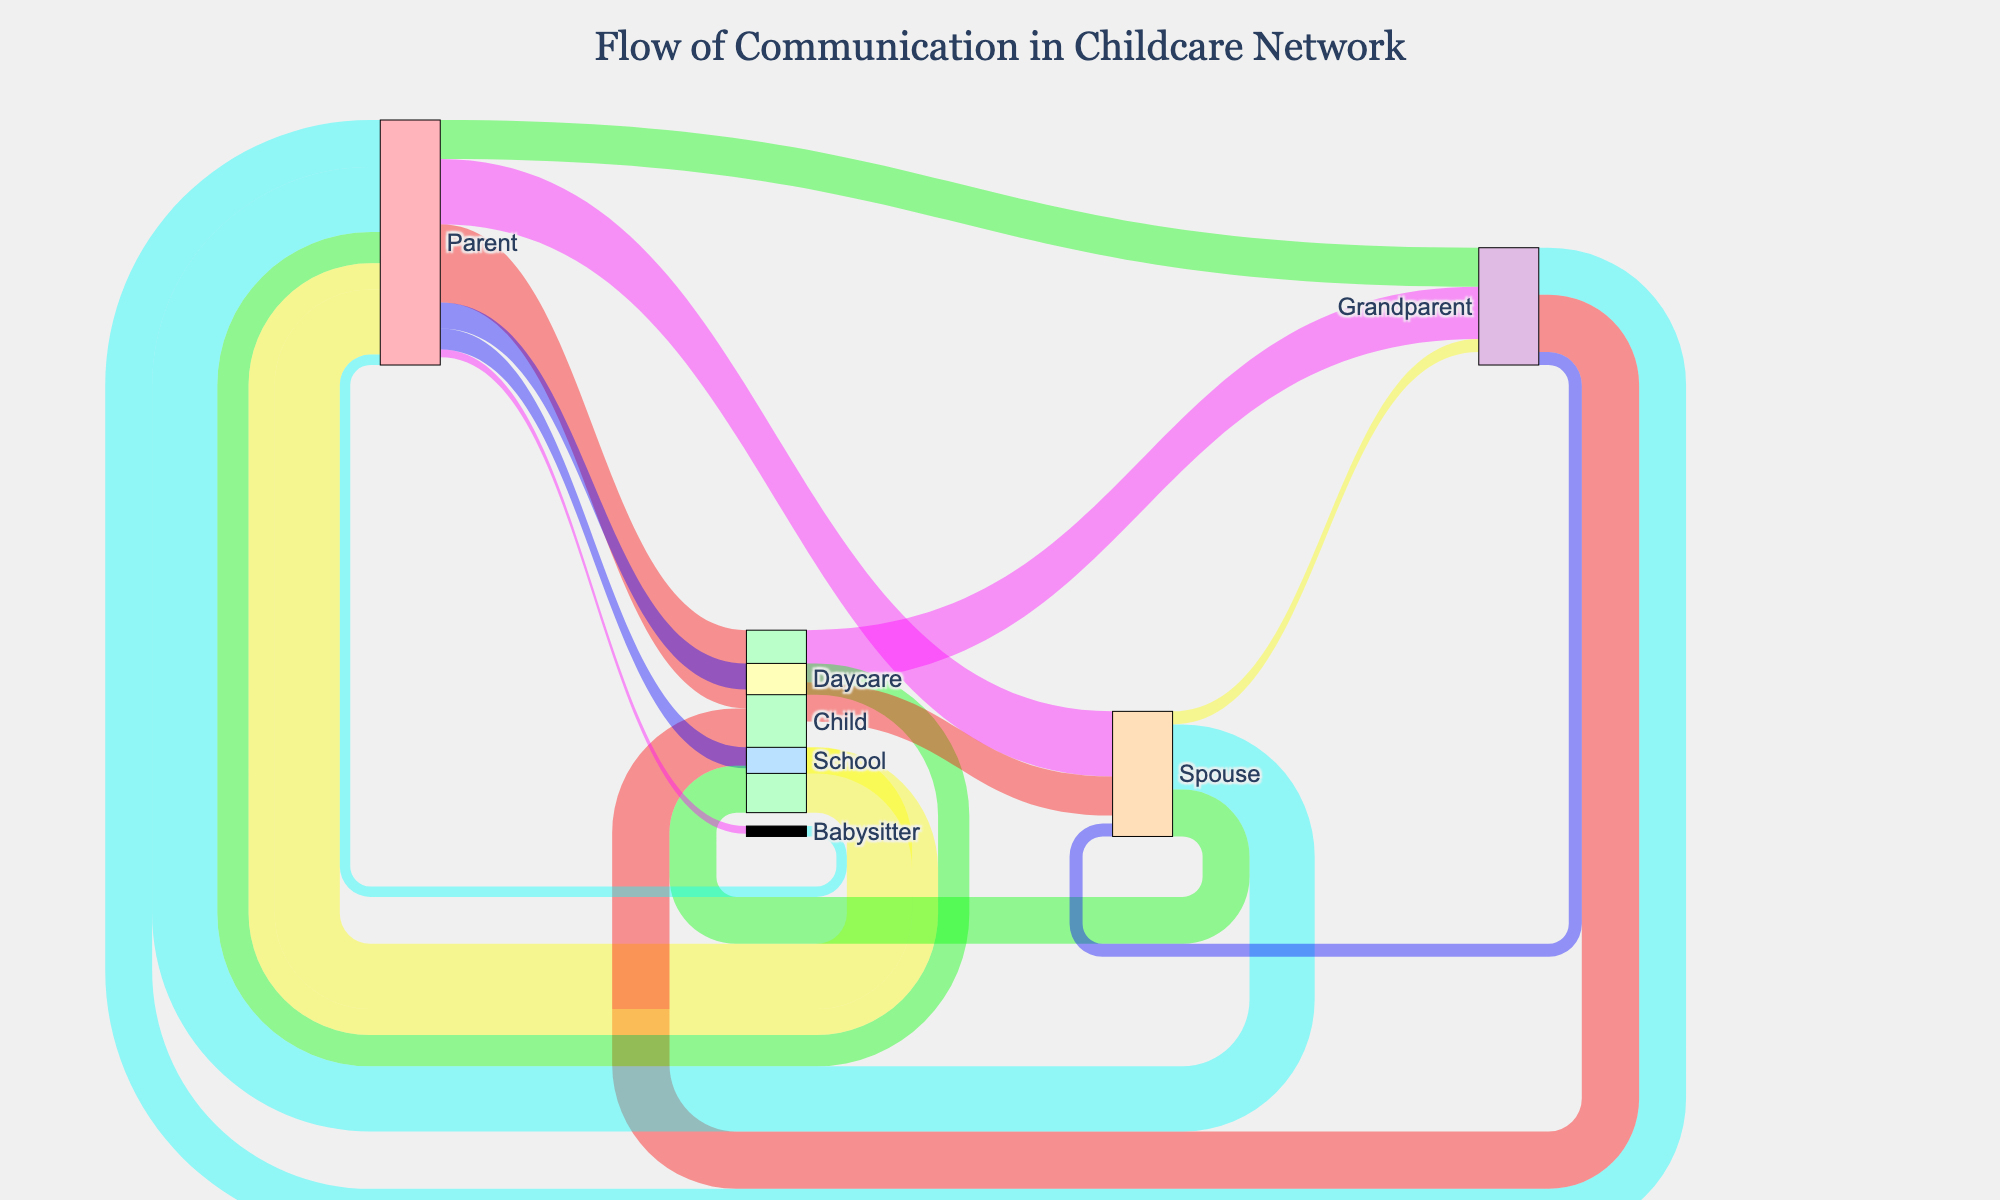what is the title of the plot? The title is written at the top of the figure and typically summarizes the main information conveyed by the chart.
Answer: "Flow of Communication in Childcare Network" Which node has the highest outgoing communication with parents? Look at the nodes connected by arrows originating from "Parent". The node with the highest value linked to the "Parent" node by an arrow is the one.
Answer: Child How many channels of communication involve grandparents altogether? Count all the arrows that either originate from or end in the "Grandparent" node.
Answer: 7 What is the combined communication between parents and their children in both directions? Consider both directions of communication (Parent to Child and Child to Parent). Sum the values of the arrows in each direction.
Answer: 55 Between Parent and Daycare, which direction has more communication? Compare the values of the arrows connecting "Parent" to "Daycare" and "Daycare" to "Parent". Determine which value is greater.
Answer: Daycare to Parent Which communication flow is stronger: Parent to Grandparent or Grandparent to Parent? Look at the value of the arrows between "Parent" and "Grandparent" in both directions and compare them.
Answer: Grandparent to Parent How does the communication of parents with Spouse compare to that with Grandparents? Sum the values of "Parent to Spouse" and "Spouse to Parent", then compare this total to the sum of "Parent to Grandparent" and "Grandparent to Parent".
Answer: More with Spouse What is the range of communication values? Identify the smallest and largest values among all the arrows in the Sankey diagram. The range is the difference between these values.
Answer: 3 to 30 Which group involves more communication overall: Children's communication with Spouse or Children's communication with Grandparents? Total the values of arrows between "Child" and "Spouse", and between "Child" and "Grandparent" in both directions. Compare these totals.
Answer: Children's communication with Grandparents 